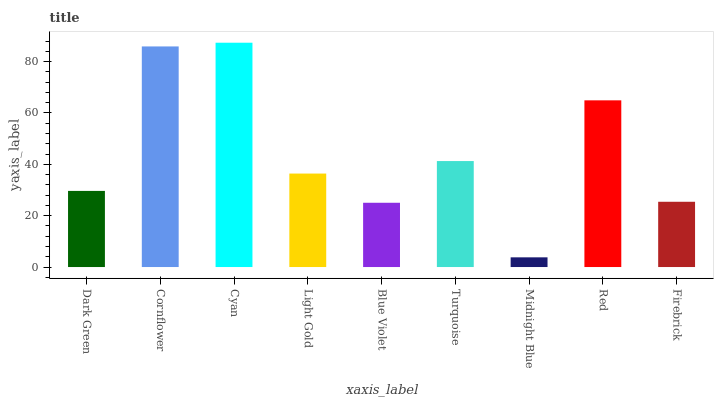Is Midnight Blue the minimum?
Answer yes or no. Yes. Is Cyan the maximum?
Answer yes or no. Yes. Is Cornflower the minimum?
Answer yes or no. No. Is Cornflower the maximum?
Answer yes or no. No. Is Cornflower greater than Dark Green?
Answer yes or no. Yes. Is Dark Green less than Cornflower?
Answer yes or no. Yes. Is Dark Green greater than Cornflower?
Answer yes or no. No. Is Cornflower less than Dark Green?
Answer yes or no. No. Is Light Gold the high median?
Answer yes or no. Yes. Is Light Gold the low median?
Answer yes or no. Yes. Is Dark Green the high median?
Answer yes or no. No. Is Firebrick the low median?
Answer yes or no. No. 